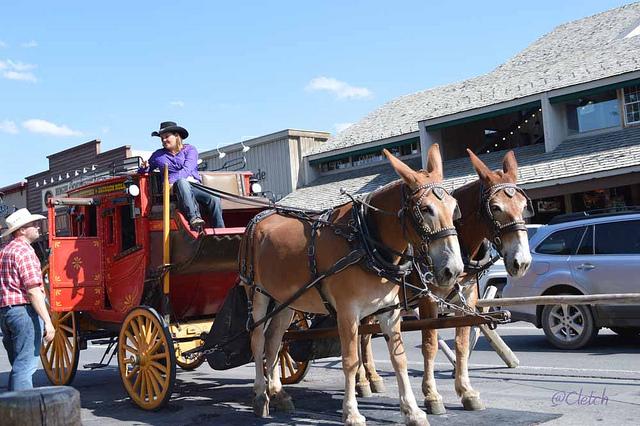What species of animals are these?
Be succinct. Horse. What is being pulled?
Keep it brief. Carriage. How many horses are pulling the wagon?
Answer briefly. 2. What are these animals pulling?
Give a very brief answer. Stagecoach. What kind of animals are shown?
Short answer required. Horses. Is the horse moving?
Be succinct. No. 